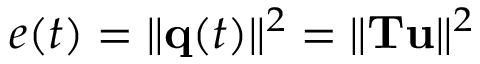<formula> <loc_0><loc_0><loc_500><loc_500>e ( t ) = \| { q } ( t ) \| ^ { 2 } = \| { T u } \| ^ { 2 }</formula> 